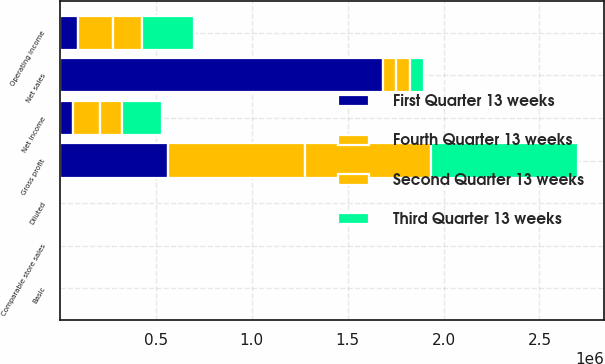Convert chart. <chart><loc_0><loc_0><loc_500><loc_500><stacked_bar_chart><ecel><fcel>Net sales<fcel>Gross profit<fcel>Operating income<fcel>Net income<fcel>Basic<fcel>Diluted<fcel>Comparable store sales<nl><fcel>First Quarter 13 weeks<fcel>1.6829e+06<fcel>563649<fcel>94749<fcel>71433<fcel>0.57<fcel>0.57<fcel>3.7<nl><fcel>Third Quarter 13 weeks<fcel>71433<fcel>769414<fcel>273458<fcel>207289<fcel>1.7<fcel>1.69<fcel>5.6<nl><fcel>Second Quarter 13 weeks<fcel>71433<fcel>653132<fcel>153148<fcel>116784<fcel>0.96<fcel>0.95<fcel>5.1<nl><fcel>Fourth Quarter 13 weeks<fcel>71433<fcel>716333<fcel>180382<fcel>136851<fcel>1.12<fcel>1.11<fcel>5.7<nl></chart> 